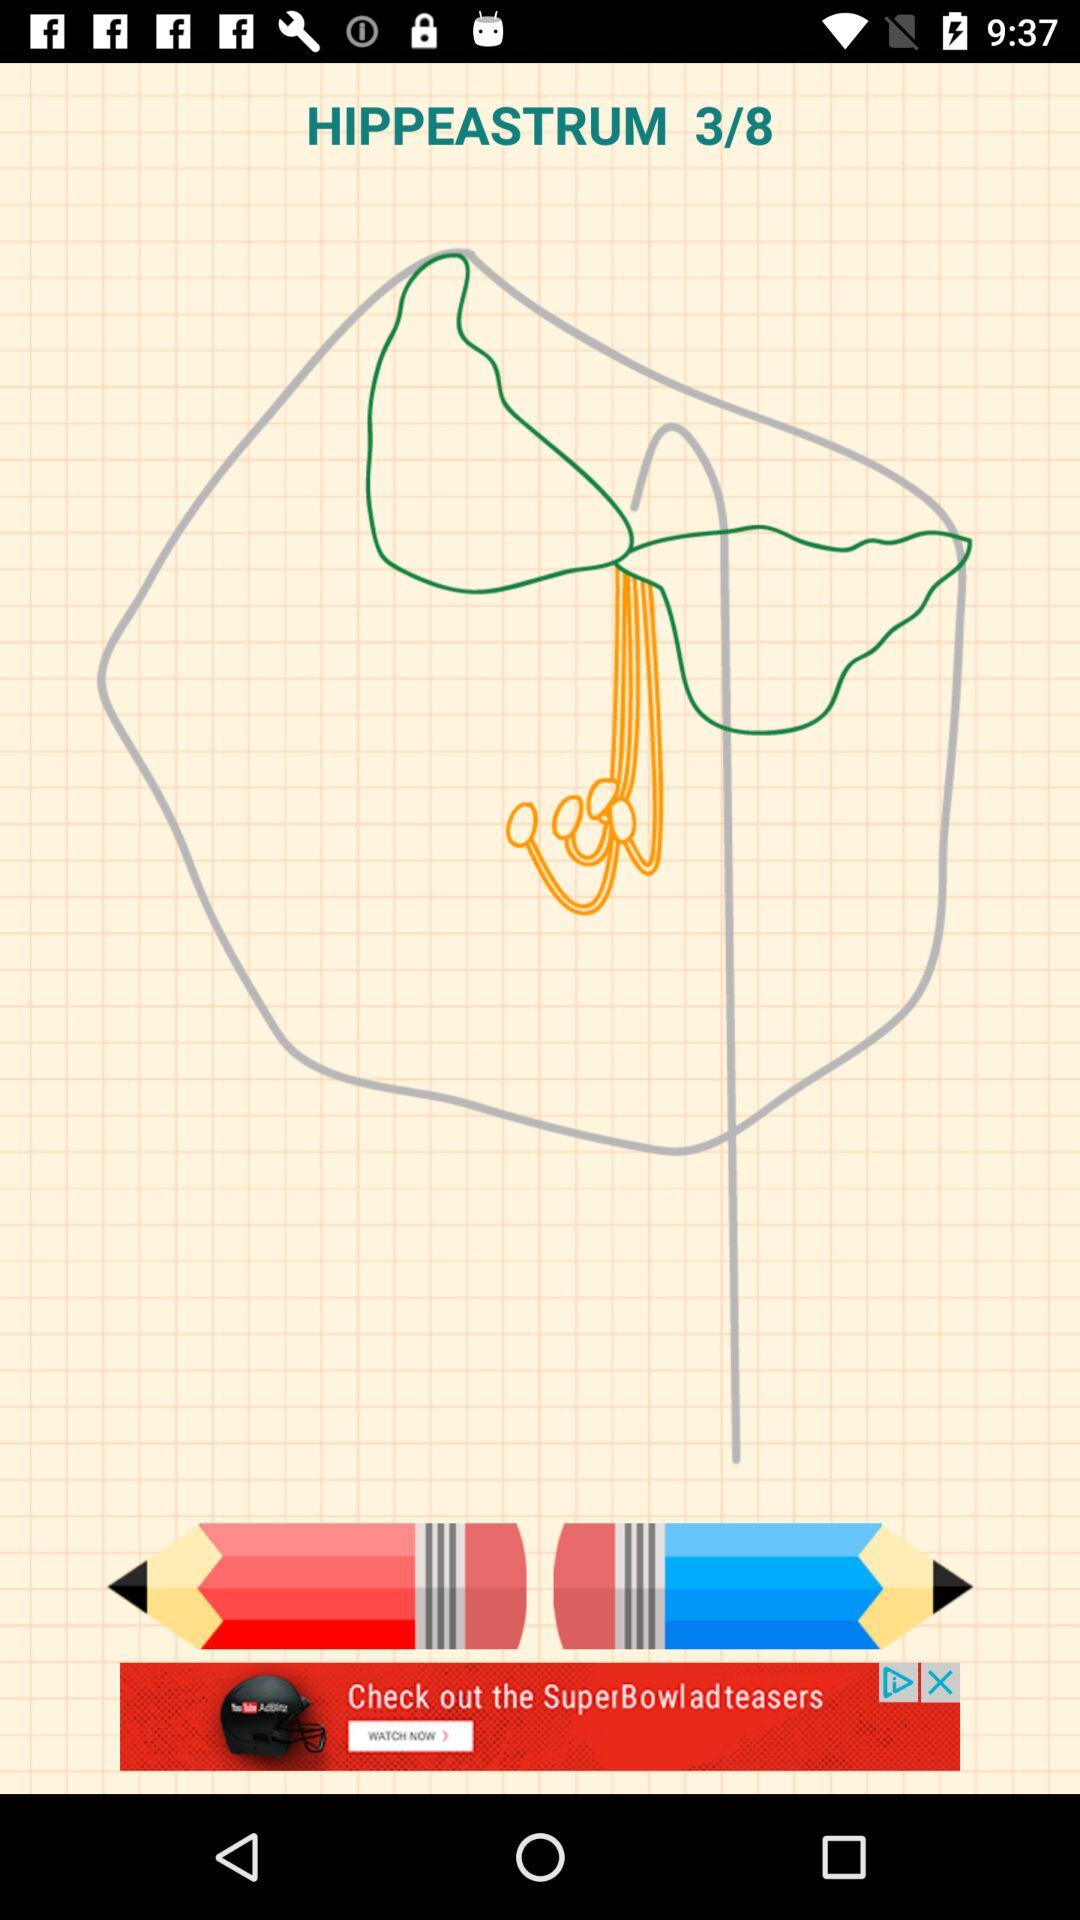How many colors are being used to draw?
When the provided information is insufficient, respond with <no answer>. <no answer> 